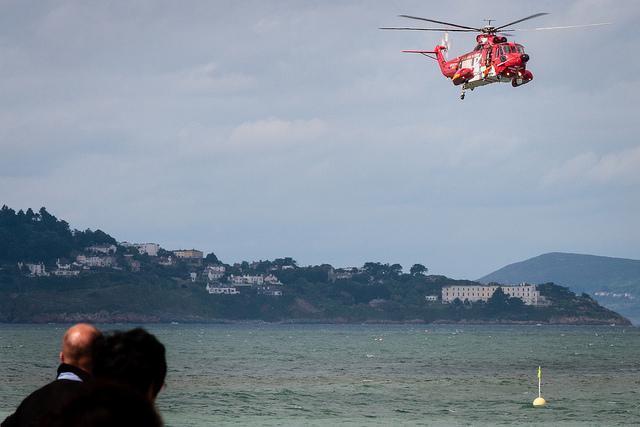How many people can you see?
Give a very brief answer. 2. 